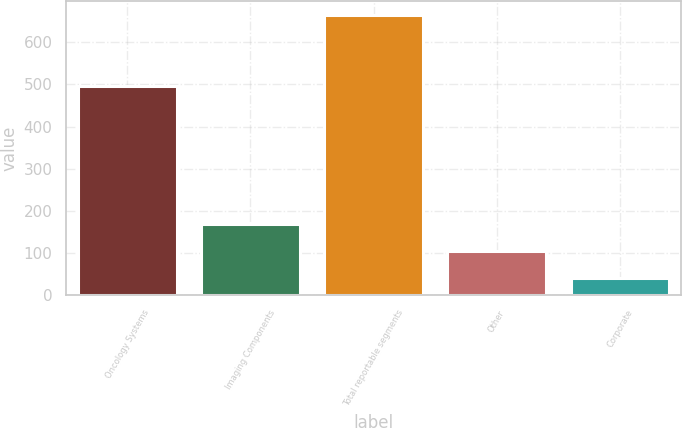<chart> <loc_0><loc_0><loc_500><loc_500><bar_chart><fcel>Oncology Systems<fcel>Imaging Components<fcel>Total reportable segments<fcel>Other<fcel>Corporate<nl><fcel>495.5<fcel>169.9<fcel>665.4<fcel>103.89<fcel>41.5<nl></chart> 